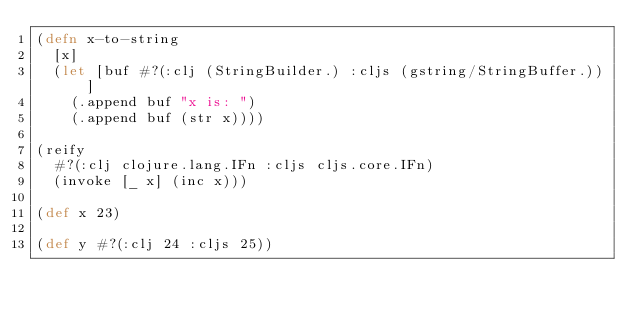<code> <loc_0><loc_0><loc_500><loc_500><_Clojure_>(defn x-to-string
  [x]
  (let [buf #?(:clj (StringBuilder.) :cljs (gstring/StringBuffer.))]
    (.append buf "x is: ")
    (.append buf (str x))))

(reify
  #?(:clj clojure.lang.IFn :cljs cljs.core.IFn)
  (invoke [_ x] (inc x)))

(def x 23)

(def y #?(:clj 24 :cljs 25))</code> 